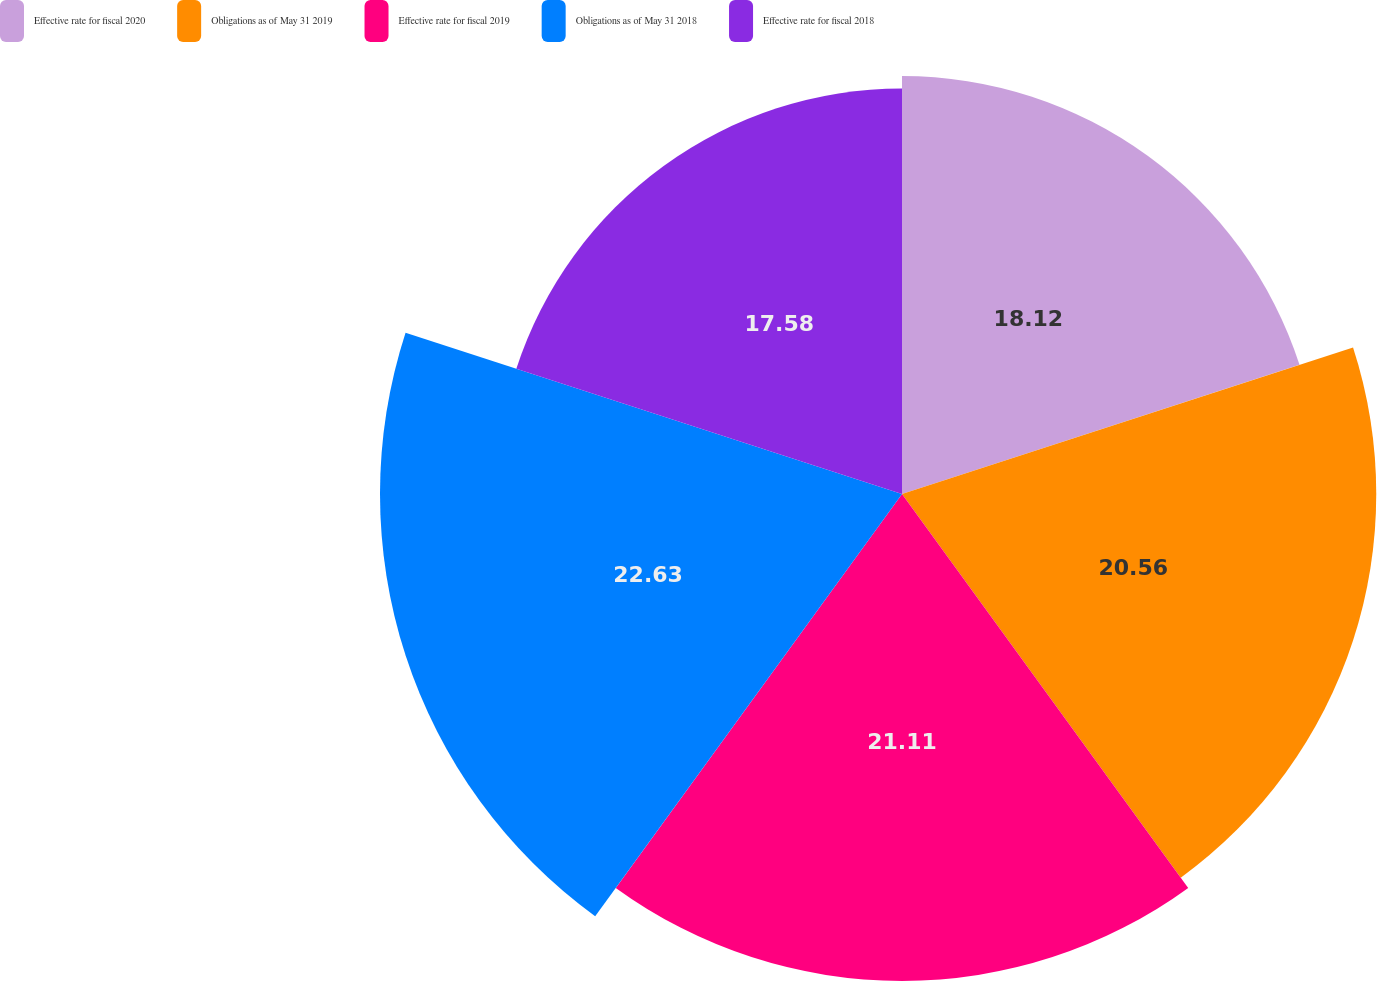Convert chart to OTSL. <chart><loc_0><loc_0><loc_500><loc_500><pie_chart><fcel>Effective rate for fiscal 2020<fcel>Obligations as of May 31 2019<fcel>Effective rate for fiscal 2019<fcel>Obligations as of May 31 2018<fcel>Effective rate for fiscal 2018<nl><fcel>18.12%<fcel>20.56%<fcel>21.11%<fcel>22.63%<fcel>17.58%<nl></chart> 